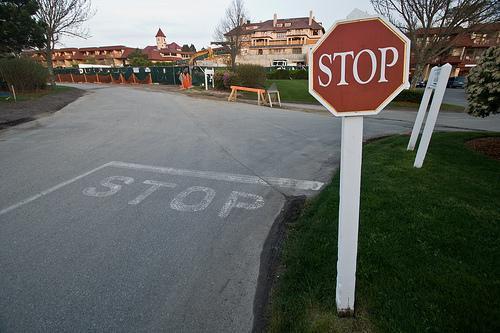How many stop signs are there?
Give a very brief answer. 1. How many "stop"s are on the ground?
Give a very brief answer. 1. 